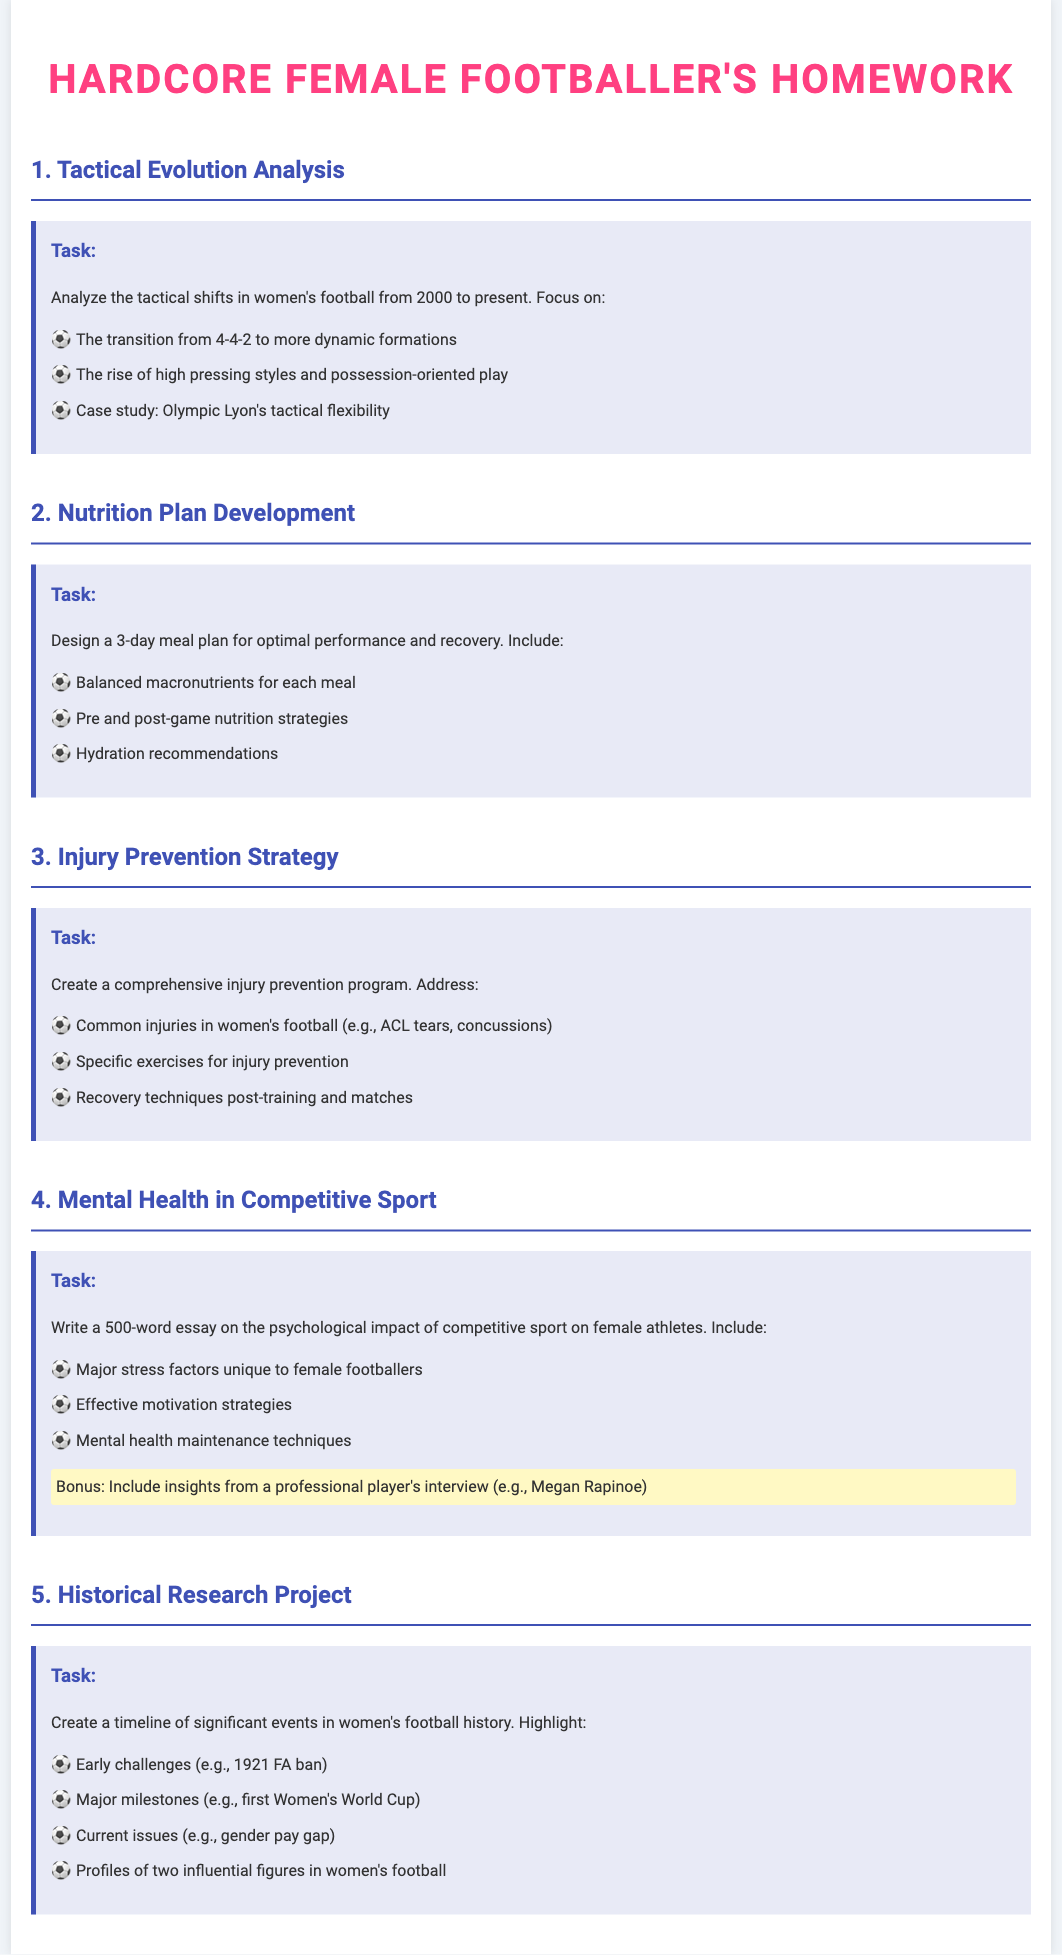What is the title of the homework document? The title of the homework document is located at the top of the page.
Answer: Hardcore Female Footballer's Homework What are the three main topics covered in the nutrition section? The nutrition section lists specific elements related to meal planning for athletes.
Answer: Balanced macronutrients, Pre and post-game nutrition strategies, Hydration recommendations Which formation is associated with the tactical evolution analysis from 2000 to present? The tactical evolution section specifies the formation's transition over the years.
Answer: 4-4-2 What is one common injury noted in the injury prevention strategy? The injury prevention section lists specific injuries common in women's football.
Answer: ACL tears Who is suggested for the bonus insight in the mental health section? The mental health section includes an interview possibility for additional insights.
Answer: Megan Rapinoe 